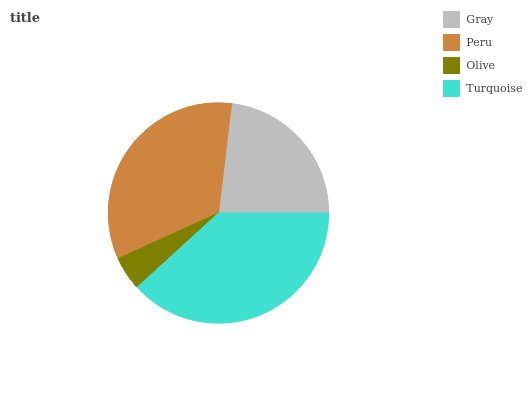Is Olive the minimum?
Answer yes or no. Yes. Is Turquoise the maximum?
Answer yes or no. Yes. Is Peru the minimum?
Answer yes or no. No. Is Peru the maximum?
Answer yes or no. No. Is Peru greater than Gray?
Answer yes or no. Yes. Is Gray less than Peru?
Answer yes or no. Yes. Is Gray greater than Peru?
Answer yes or no. No. Is Peru less than Gray?
Answer yes or no. No. Is Peru the high median?
Answer yes or no. Yes. Is Gray the low median?
Answer yes or no. Yes. Is Olive the high median?
Answer yes or no. No. Is Turquoise the low median?
Answer yes or no. No. 